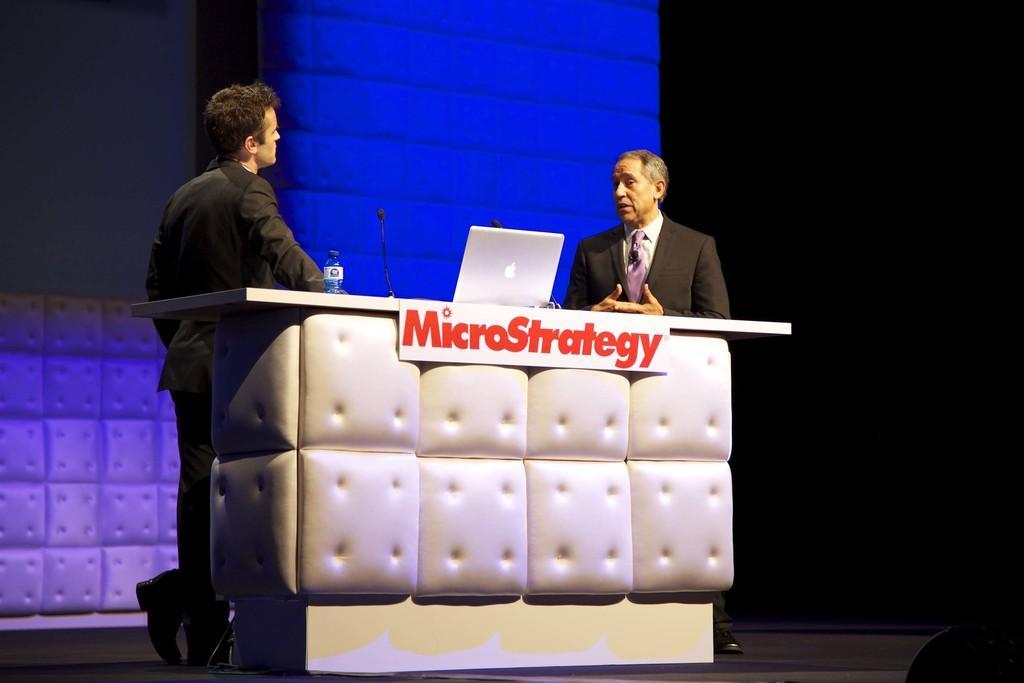Could you give a brief overview of what you see in this image? In this image there are two persons standing in front of the table. On the table there is a laptop, water bottle and mics. In the background there is a wall. 